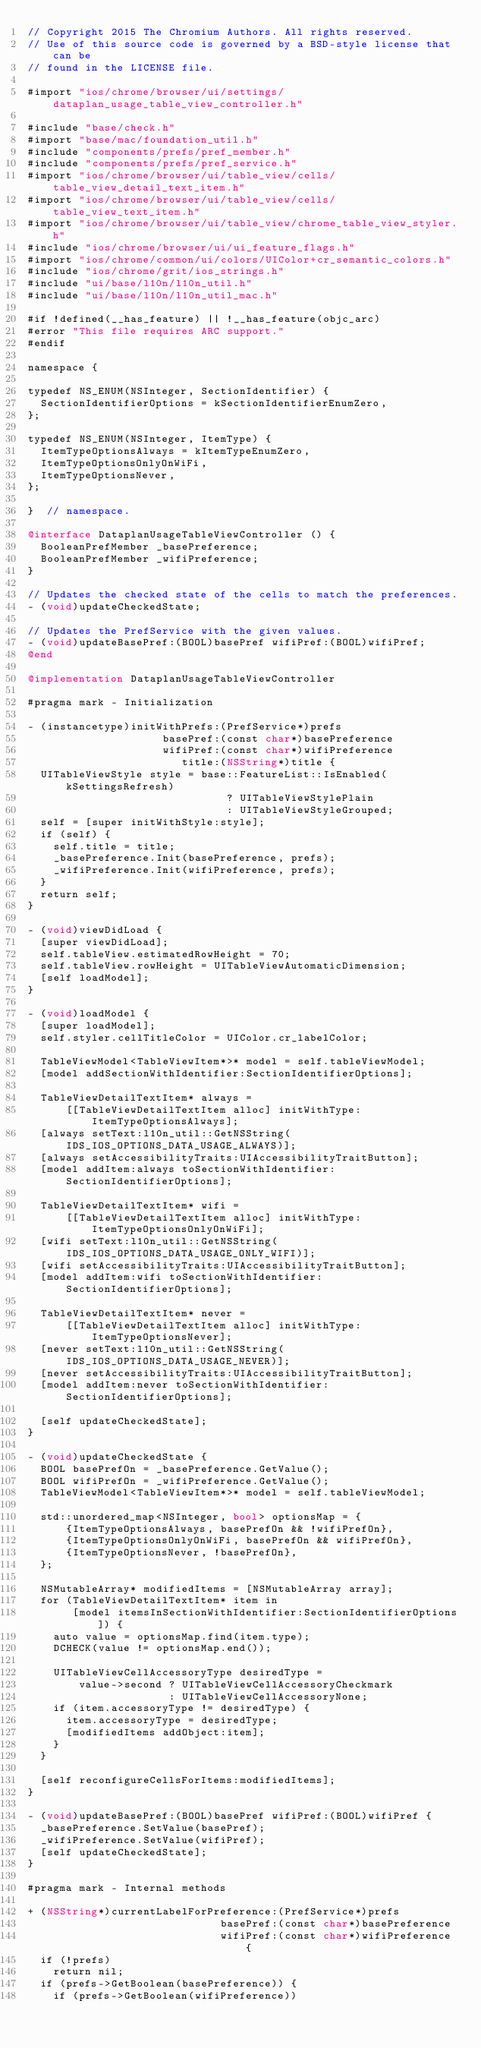<code> <loc_0><loc_0><loc_500><loc_500><_ObjectiveC_>// Copyright 2015 The Chromium Authors. All rights reserved.
// Use of this source code is governed by a BSD-style license that can be
// found in the LICENSE file.

#import "ios/chrome/browser/ui/settings/dataplan_usage_table_view_controller.h"

#include "base/check.h"
#import "base/mac/foundation_util.h"
#include "components/prefs/pref_member.h"
#include "components/prefs/pref_service.h"
#import "ios/chrome/browser/ui/table_view/cells/table_view_detail_text_item.h"
#import "ios/chrome/browser/ui/table_view/cells/table_view_text_item.h"
#import "ios/chrome/browser/ui/table_view/chrome_table_view_styler.h"
#include "ios/chrome/browser/ui/ui_feature_flags.h"
#import "ios/chrome/common/ui/colors/UIColor+cr_semantic_colors.h"
#include "ios/chrome/grit/ios_strings.h"
#include "ui/base/l10n/l10n_util.h"
#include "ui/base/l10n/l10n_util_mac.h"

#if !defined(__has_feature) || !__has_feature(objc_arc)
#error "This file requires ARC support."
#endif

namespace {

typedef NS_ENUM(NSInteger, SectionIdentifier) {
  SectionIdentifierOptions = kSectionIdentifierEnumZero,
};

typedef NS_ENUM(NSInteger, ItemType) {
  ItemTypeOptionsAlways = kItemTypeEnumZero,
  ItemTypeOptionsOnlyOnWiFi,
  ItemTypeOptionsNever,
};

}  // namespace.

@interface DataplanUsageTableViewController () {
  BooleanPrefMember _basePreference;
  BooleanPrefMember _wifiPreference;
}

// Updates the checked state of the cells to match the preferences.
- (void)updateCheckedState;

// Updates the PrefService with the given values.
- (void)updateBasePref:(BOOL)basePref wifiPref:(BOOL)wifiPref;
@end

@implementation DataplanUsageTableViewController

#pragma mark - Initialization

- (instancetype)initWithPrefs:(PrefService*)prefs
                     basePref:(const char*)basePreference
                     wifiPref:(const char*)wifiPreference
                        title:(NSString*)title {
  UITableViewStyle style = base::FeatureList::IsEnabled(kSettingsRefresh)
                               ? UITableViewStylePlain
                               : UITableViewStyleGrouped;
  self = [super initWithStyle:style];
  if (self) {
    self.title = title;
    _basePreference.Init(basePreference, prefs);
    _wifiPreference.Init(wifiPreference, prefs);
  }
  return self;
}

- (void)viewDidLoad {
  [super viewDidLoad];
  self.tableView.estimatedRowHeight = 70;
  self.tableView.rowHeight = UITableViewAutomaticDimension;
  [self loadModel];
}

- (void)loadModel {
  [super loadModel];
  self.styler.cellTitleColor = UIColor.cr_labelColor;

  TableViewModel<TableViewItem*>* model = self.tableViewModel;
  [model addSectionWithIdentifier:SectionIdentifierOptions];

  TableViewDetailTextItem* always =
      [[TableViewDetailTextItem alloc] initWithType:ItemTypeOptionsAlways];
  [always setText:l10n_util::GetNSString(IDS_IOS_OPTIONS_DATA_USAGE_ALWAYS)];
  [always setAccessibilityTraits:UIAccessibilityTraitButton];
  [model addItem:always toSectionWithIdentifier:SectionIdentifierOptions];

  TableViewDetailTextItem* wifi =
      [[TableViewDetailTextItem alloc] initWithType:ItemTypeOptionsOnlyOnWiFi];
  [wifi setText:l10n_util::GetNSString(IDS_IOS_OPTIONS_DATA_USAGE_ONLY_WIFI)];
  [wifi setAccessibilityTraits:UIAccessibilityTraitButton];
  [model addItem:wifi toSectionWithIdentifier:SectionIdentifierOptions];

  TableViewDetailTextItem* never =
      [[TableViewDetailTextItem alloc] initWithType:ItemTypeOptionsNever];
  [never setText:l10n_util::GetNSString(IDS_IOS_OPTIONS_DATA_USAGE_NEVER)];
  [never setAccessibilityTraits:UIAccessibilityTraitButton];
  [model addItem:never toSectionWithIdentifier:SectionIdentifierOptions];

  [self updateCheckedState];
}

- (void)updateCheckedState {
  BOOL basePrefOn = _basePreference.GetValue();
  BOOL wifiPrefOn = _wifiPreference.GetValue();
  TableViewModel<TableViewItem*>* model = self.tableViewModel;

  std::unordered_map<NSInteger, bool> optionsMap = {
      {ItemTypeOptionsAlways, basePrefOn && !wifiPrefOn},
      {ItemTypeOptionsOnlyOnWiFi, basePrefOn && wifiPrefOn},
      {ItemTypeOptionsNever, !basePrefOn},
  };

  NSMutableArray* modifiedItems = [NSMutableArray array];
  for (TableViewDetailTextItem* item in
       [model itemsInSectionWithIdentifier:SectionIdentifierOptions]) {
    auto value = optionsMap.find(item.type);
    DCHECK(value != optionsMap.end());

    UITableViewCellAccessoryType desiredType =
        value->second ? UITableViewCellAccessoryCheckmark
                      : UITableViewCellAccessoryNone;
    if (item.accessoryType != desiredType) {
      item.accessoryType = desiredType;
      [modifiedItems addObject:item];
    }
  }

  [self reconfigureCellsForItems:modifiedItems];
}

- (void)updateBasePref:(BOOL)basePref wifiPref:(BOOL)wifiPref {
  _basePreference.SetValue(basePref);
  _wifiPreference.SetValue(wifiPref);
  [self updateCheckedState];
}

#pragma mark - Internal methods

+ (NSString*)currentLabelForPreference:(PrefService*)prefs
                              basePref:(const char*)basePreference
                              wifiPref:(const char*)wifiPreference {
  if (!prefs)
    return nil;
  if (prefs->GetBoolean(basePreference)) {
    if (prefs->GetBoolean(wifiPreference))</code> 